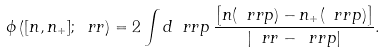<formula> <loc_0><loc_0><loc_500><loc_500>\phi \left ( [ n , n _ { + } ] ; \ r r \right ) = 2 \int d \ r r p \, \frac { \left [ n ( \ r r p ) - n _ { + } ( \ r r p ) \right ] } { \left | \ r r - \ r r p \right | } .</formula> 